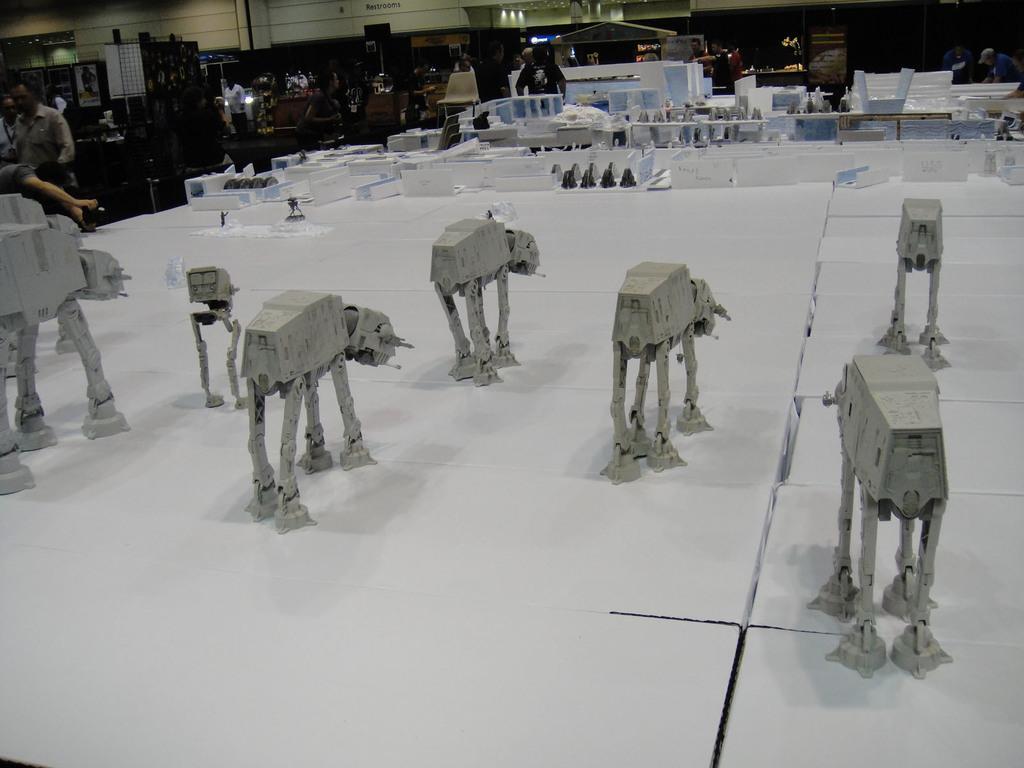Please provide a concise description of this image. In this picture, we see some statues which look like robots. In front of that, there are name boards or white color boards with some text written on it. Beside that, we see plastic boxes in white color. In the background, we see people standing. Behind them, we see a building in white color. At the bottom of the picture, we see a table which is covered with white color cloth. 